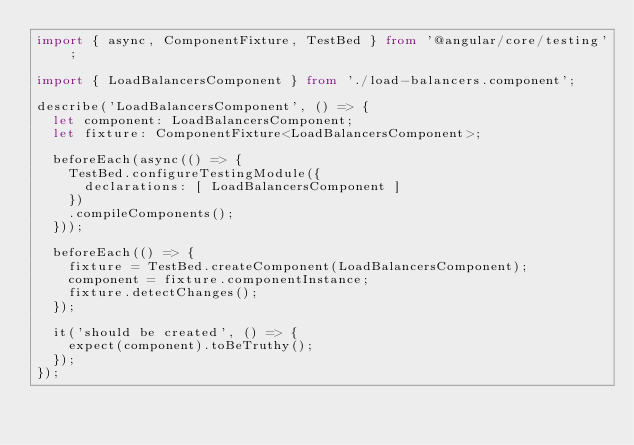<code> <loc_0><loc_0><loc_500><loc_500><_TypeScript_>import { async, ComponentFixture, TestBed } from '@angular/core/testing';

import { LoadBalancersComponent } from './load-balancers.component';

describe('LoadBalancersComponent', () => {
  let component: LoadBalancersComponent;
  let fixture: ComponentFixture<LoadBalancersComponent>;

  beforeEach(async(() => {
    TestBed.configureTestingModule({
      declarations: [ LoadBalancersComponent ]
    })
    .compileComponents();
  }));

  beforeEach(() => {
    fixture = TestBed.createComponent(LoadBalancersComponent);
    component = fixture.componentInstance;
    fixture.detectChanges();
  });

  it('should be created', () => {
    expect(component).toBeTruthy();
  });
});
</code> 